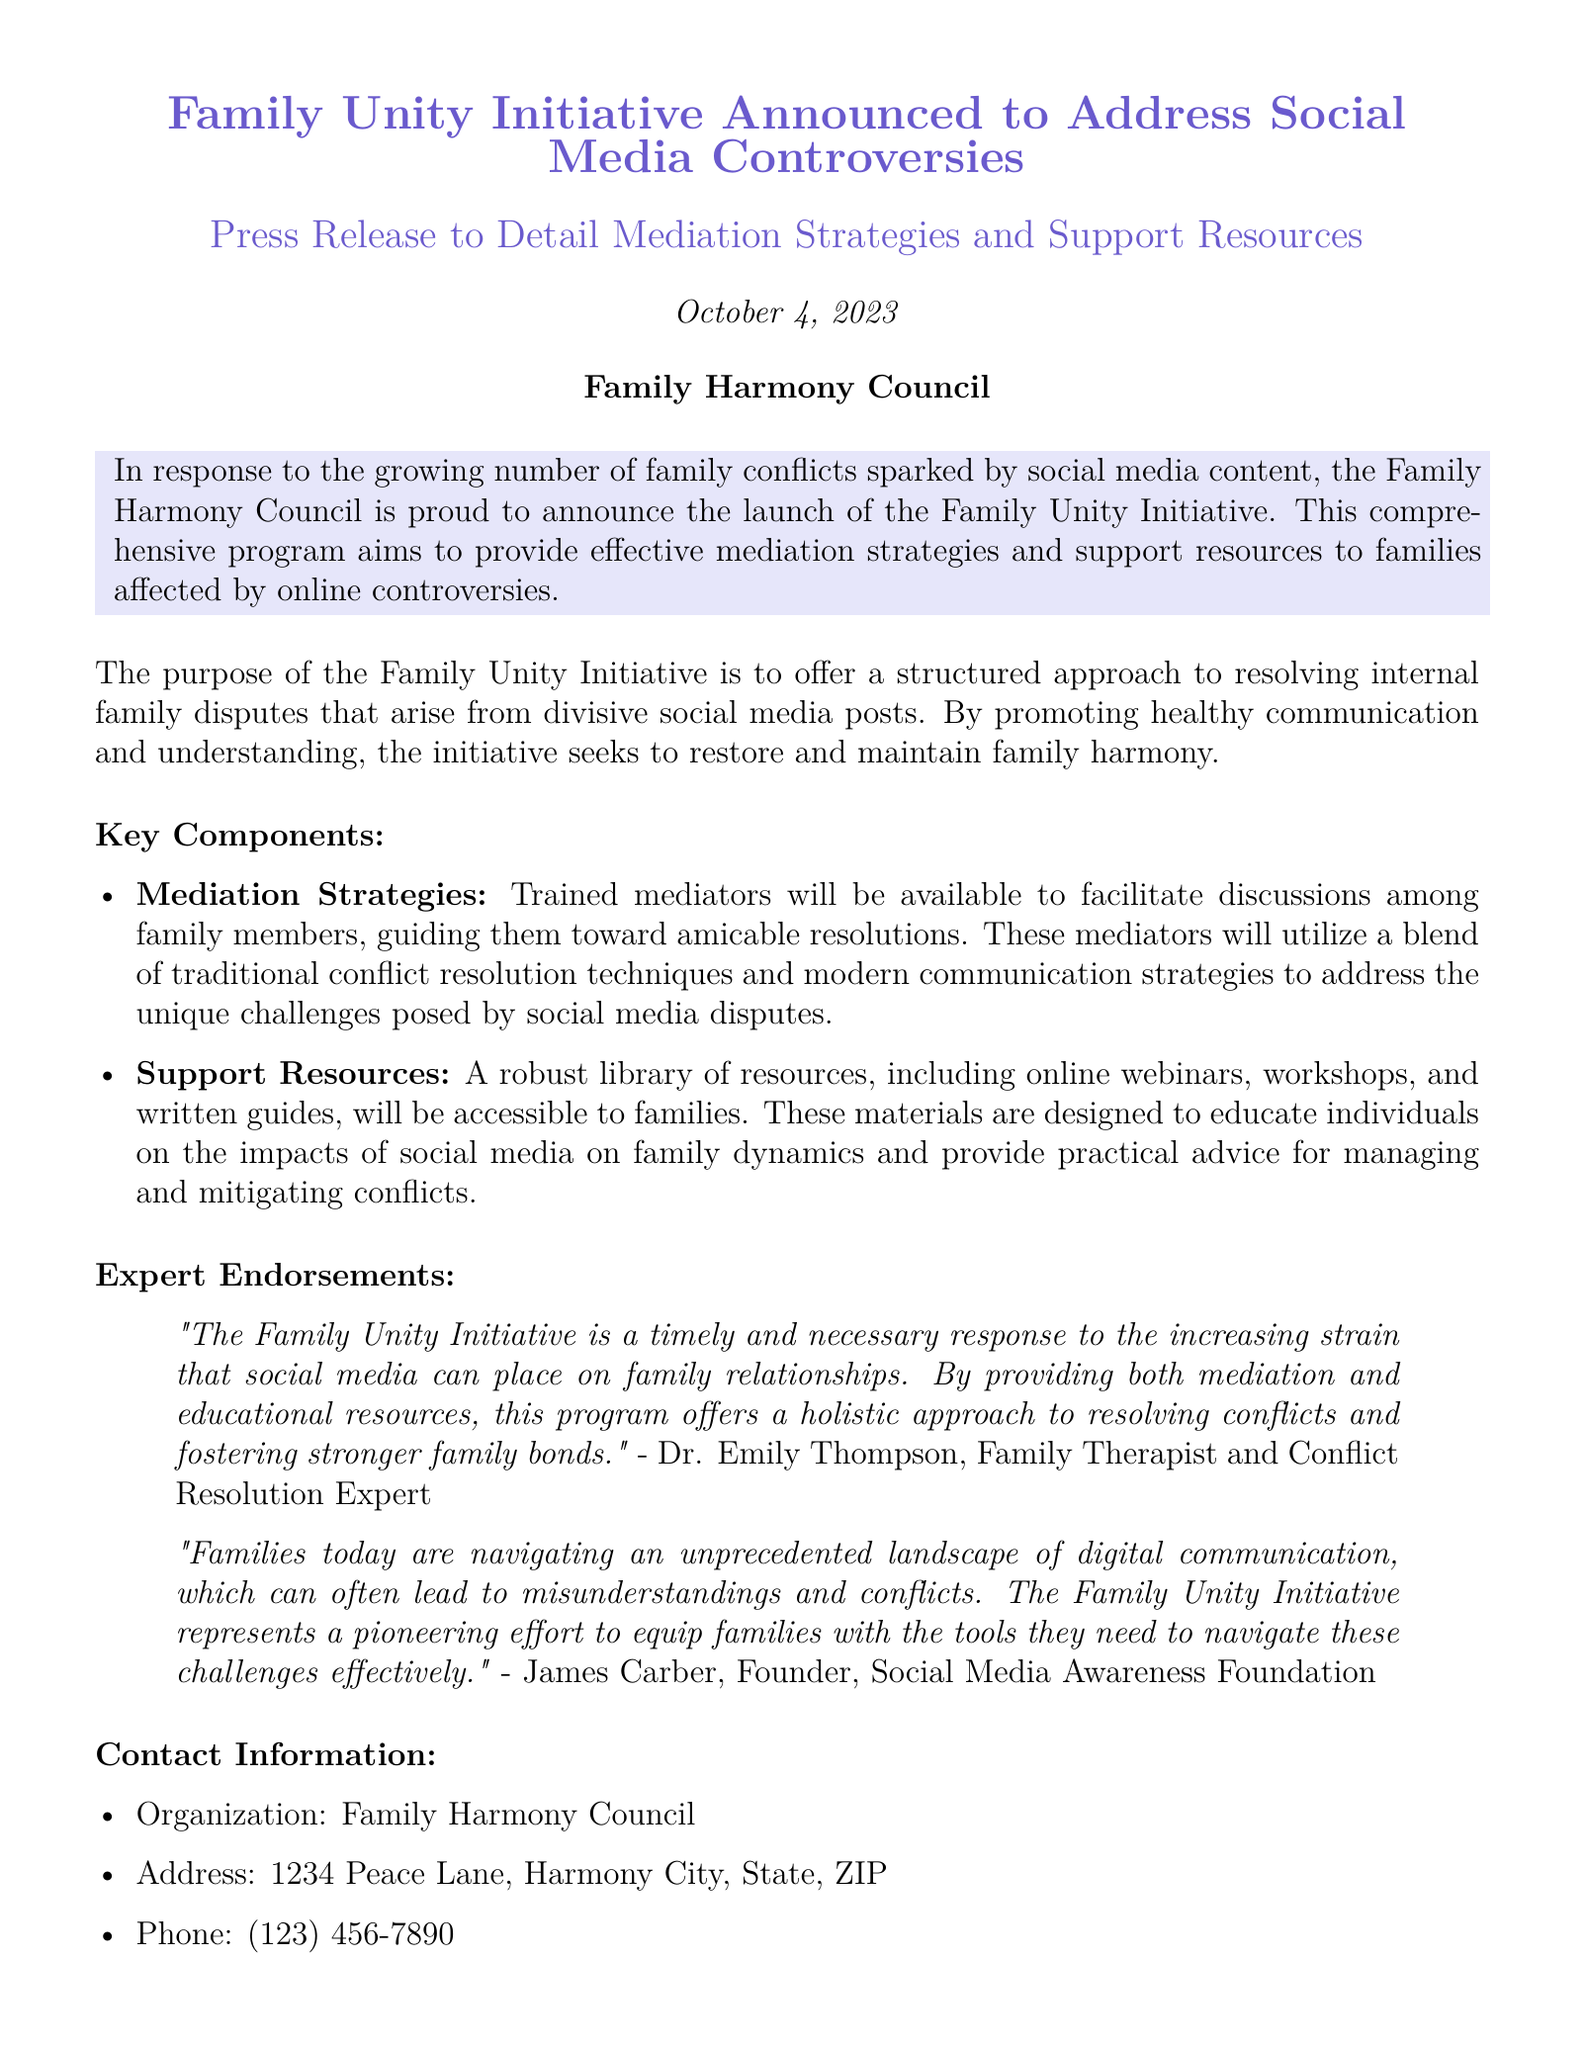What is the name of the initiative announced? The name of the initiative that was announced is directly mentioned in the document.
Answer: Family Unity Initiative When was the Family Unity Initiative announced? The announcement date is specified in the document.
Answer: October 4, 2023 Who is the organization behind the Family Unity Initiative? The document clearly states the organization responsible for the initiative.
Answer: Family Harmony Council What type of resources will be provided to families? The document lists the types of resources intended for families.
Answer: Support Resources Who provided expert endorsement for the initiative? The document includes the names of individuals who endorsed the initiative.
Answer: Dr. Emily Thompson, James Carber What issue does the Family Unity Initiative aim to address? The document describes the primary social issue the initiative is focused on.
Answer: Family conflicts sparked by social media content What is one key component of the initiative mentioned? The document specifies different components of the initiative.
Answer: Mediation Strategies What kind of approach does the initiative promote among family members? The document outlines the intended approach for family interactions.
Answer: Healthy communication and understanding 